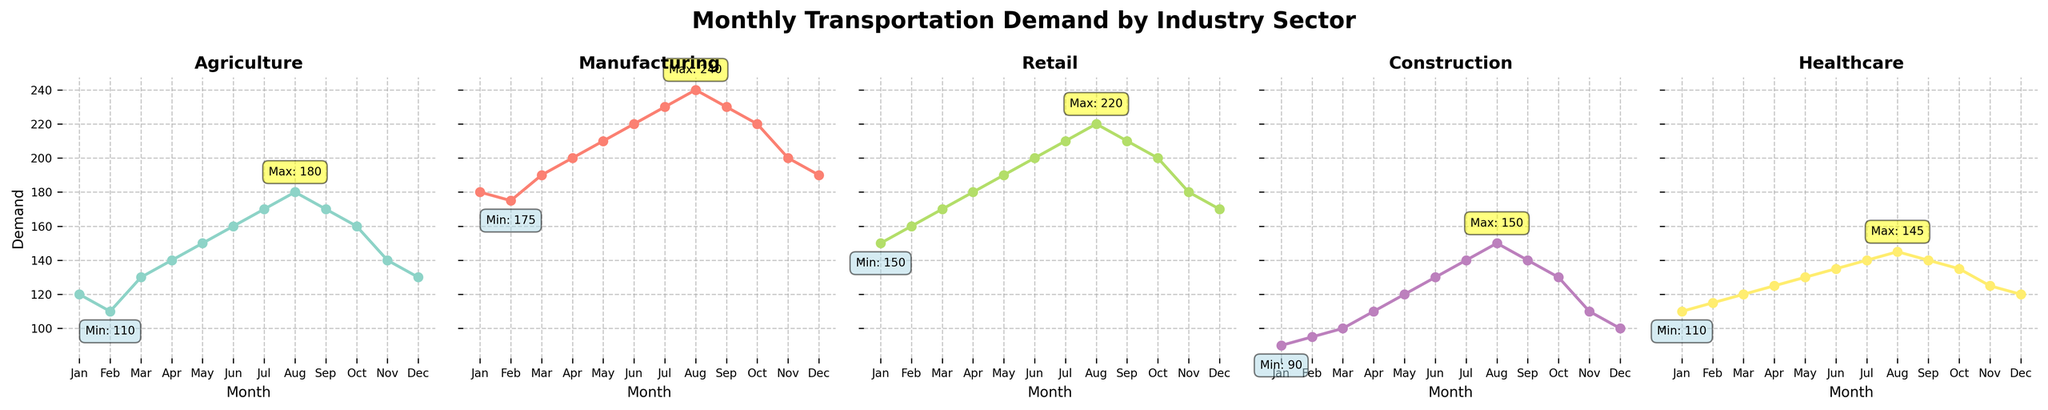What month shows the highest demand for Retail? To find the highest demand for Retail, look at the Retail subplot and identify the month where the line peaks. According to the plot, the demand peaks in August.
Answer: August Which industry has the smallest range in monthly demand? To determine the smallest range, calculate the difference between the maximum and minimum demand for each industry. Observing the plots, the difference between maximum and minimum demand is smallest for Healthcare.
Answer: Healthcare In which month do Agriculture and Retail both have the maximum demand respectively? First, identify the maximum demand for Agriculture and Retail separately, and then note their months. Agriculture peaks in August with 180 units, and Retail also peaks in August with 220 units. Therefore, both industries have their maximum demand in August.
Answer: August Which industry has the steepest increase from January to August? Compare the slopes of the lines from January to August for each subplot. The industry with the steepest increase will have the most vertical rise. Manufacturing shows the steepest increase from January (180) to August (240), a rise of 60 units.
Answer: Manufacturing What is the difference in demand for Construction between May and October? Subtract the demand in October (130) from the demand in May (120) for Construction. May - October: 130 - 120 = 10 units.
Answer: 10 units How many industries have a visible peak in August? Analyze the plots to count the number of distinct peaks occurring in August. By examining, Agriculture, Manufacturing, Retail, and Healthcare each visually peak in August.
Answer: Four industries Which industry shows the most variability in its demand throughout the year? To determine variability, compare the fluctuation range of each industry by examining the peaks and troughs. Agriculture shows significant variability, ranging from 110 to 180 units.
Answer: Agriculture What is the average demand for Healthcare over the year? Add monthly demands for Healthcare and divide by 12. (110 + 115 + 120 + 125 + 130 + 135 + 140 + 145 + 140 + 135 + 125 + 120) / 12 = 130
Answer: 130 